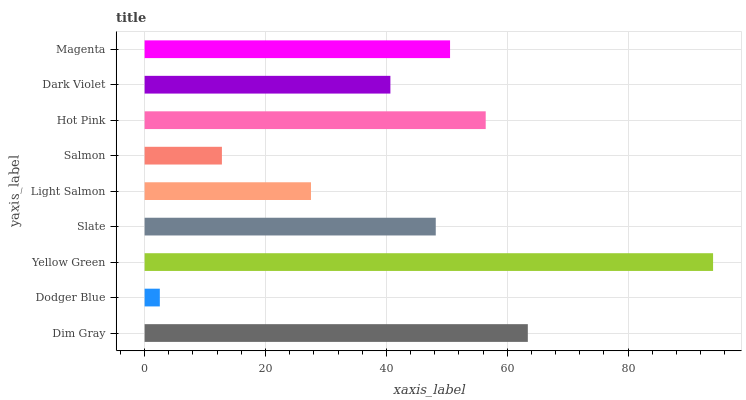Is Dodger Blue the minimum?
Answer yes or no. Yes. Is Yellow Green the maximum?
Answer yes or no. Yes. Is Yellow Green the minimum?
Answer yes or no. No. Is Dodger Blue the maximum?
Answer yes or no. No. Is Yellow Green greater than Dodger Blue?
Answer yes or no. Yes. Is Dodger Blue less than Yellow Green?
Answer yes or no. Yes. Is Dodger Blue greater than Yellow Green?
Answer yes or no. No. Is Yellow Green less than Dodger Blue?
Answer yes or no. No. Is Slate the high median?
Answer yes or no. Yes. Is Slate the low median?
Answer yes or no. Yes. Is Magenta the high median?
Answer yes or no. No. Is Yellow Green the low median?
Answer yes or no. No. 